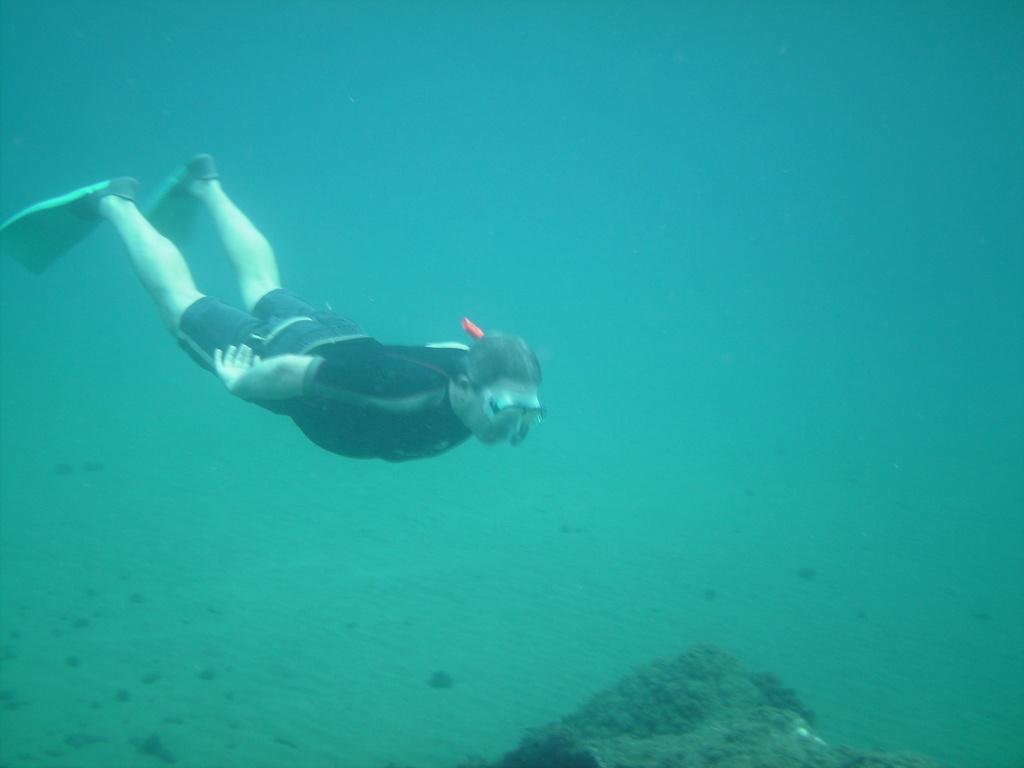How would you summarize this image in a sentence or two? In this image there is water, there is a man swimming, he is wearing goggles, there is an object towards the bottom of the image, the background of the image is blue in color. 